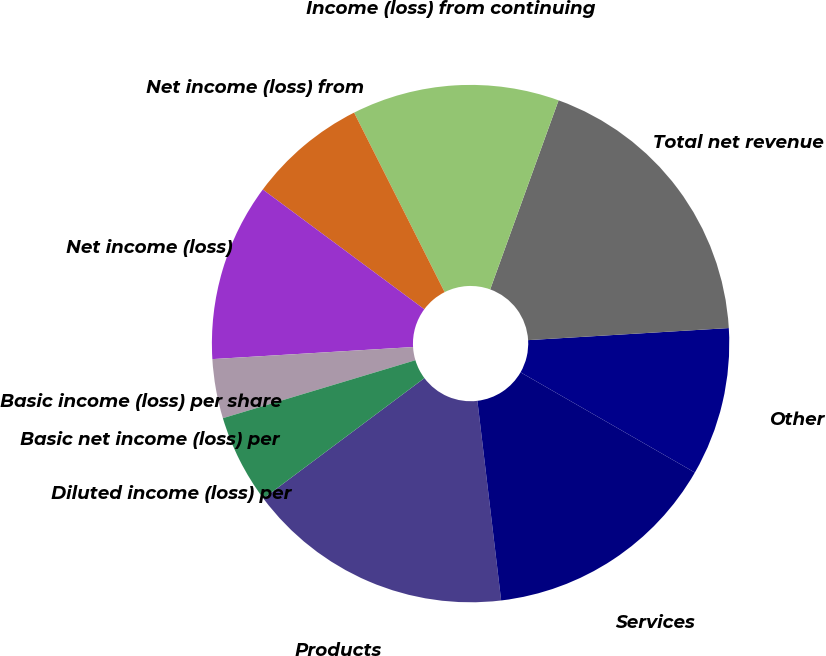Convert chart to OTSL. <chart><loc_0><loc_0><loc_500><loc_500><pie_chart><fcel>Products<fcel>Services<fcel>Other<fcel>Total net revenue<fcel>Income (loss) from continuing<fcel>Net income (loss) from<fcel>Net income (loss)<fcel>Basic income (loss) per share<fcel>Basic net income (loss) per<fcel>Diluted income (loss) per<nl><fcel>16.67%<fcel>14.81%<fcel>9.26%<fcel>18.52%<fcel>12.96%<fcel>7.41%<fcel>11.11%<fcel>3.7%<fcel>0.0%<fcel>5.56%<nl></chart> 